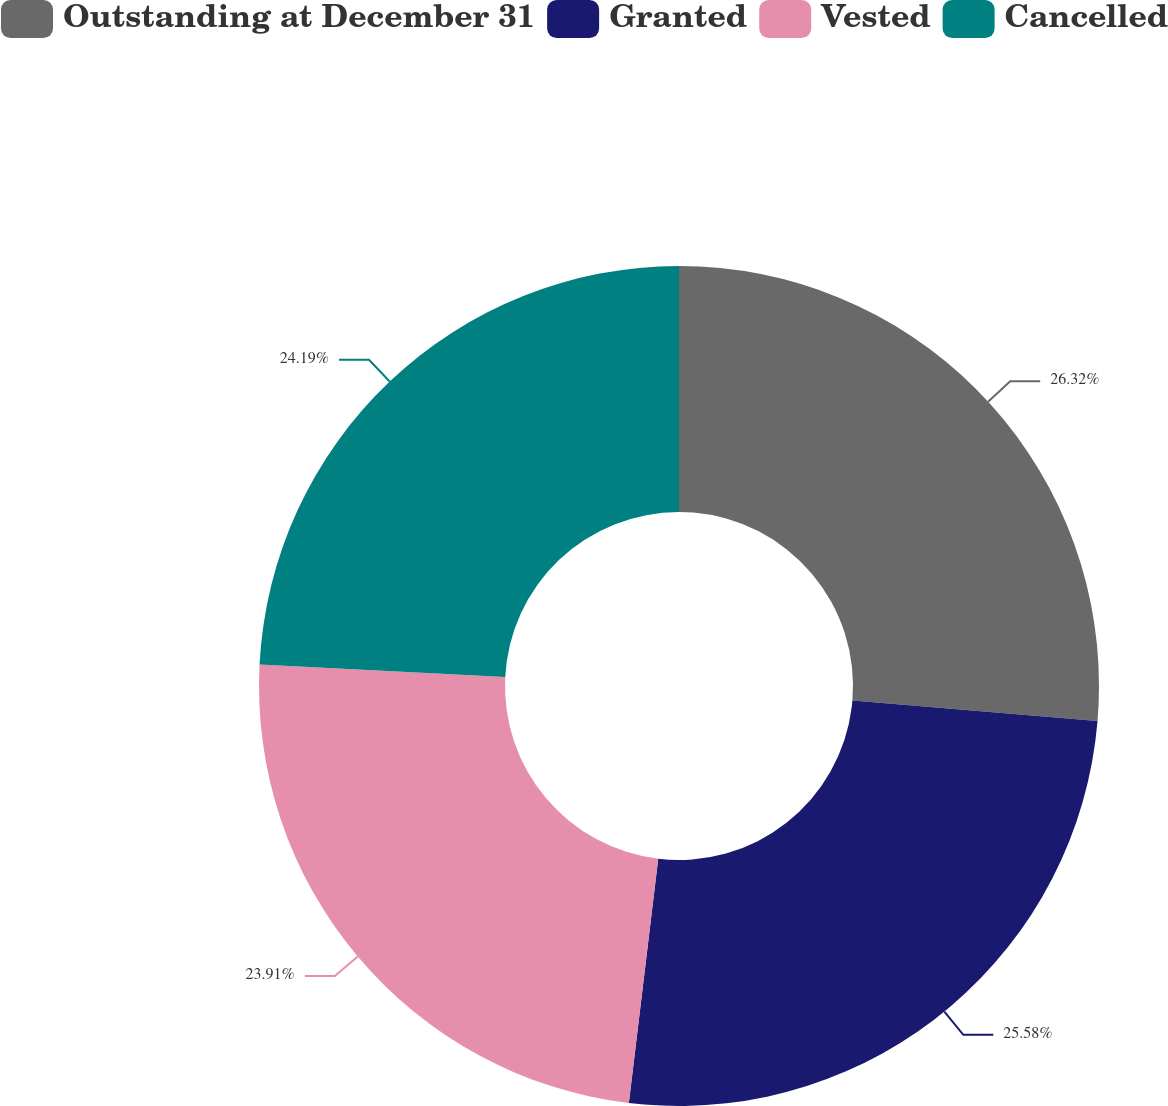<chart> <loc_0><loc_0><loc_500><loc_500><pie_chart><fcel>Outstanding at December 31<fcel>Granted<fcel>Vested<fcel>Cancelled<nl><fcel>26.33%<fcel>25.58%<fcel>23.91%<fcel>24.19%<nl></chart> 